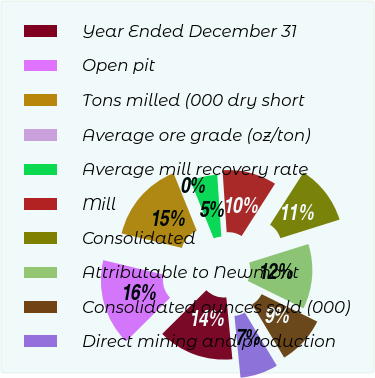Convert chart to OTSL. <chart><loc_0><loc_0><loc_500><loc_500><pie_chart><fcel>Year Ended December 31<fcel>Open pit<fcel>Tons milled (000 dry short<fcel>Average ore grade (oz/ton)<fcel>Average mill recovery rate<fcel>Mill<fcel>Consolidated<fcel>Attributable to Newmont<fcel>Consolidated ounces sold (000)<fcel>Direct mining and production<nl><fcel>14.14%<fcel>16.16%<fcel>15.15%<fcel>0.0%<fcel>5.05%<fcel>10.1%<fcel>11.11%<fcel>12.12%<fcel>9.09%<fcel>7.07%<nl></chart> 